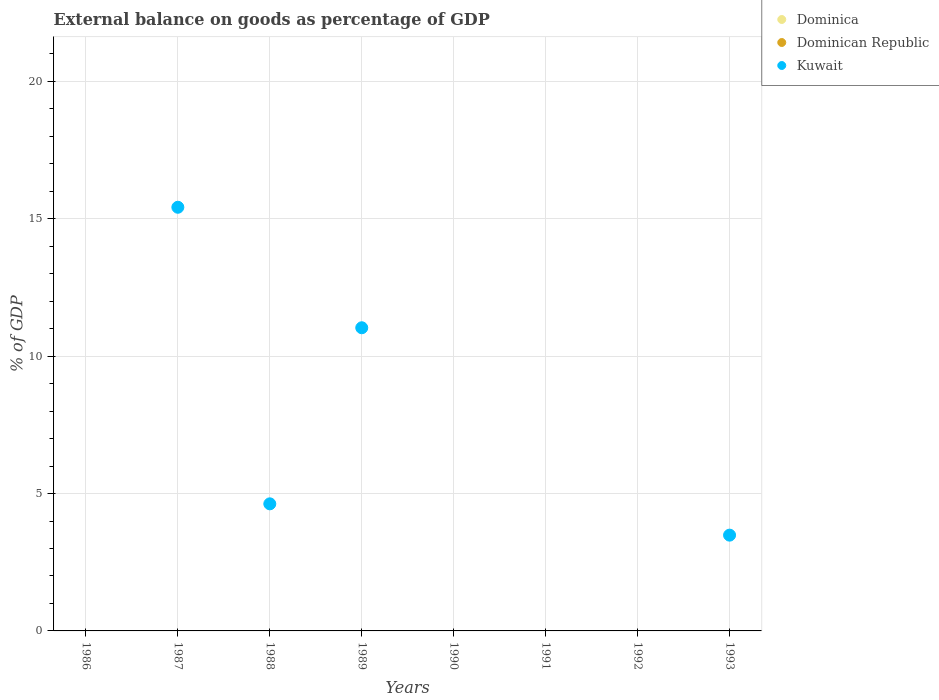Is the number of dotlines equal to the number of legend labels?
Give a very brief answer. No. Across all years, what is the maximum external balance on goods as percentage of GDP in Kuwait?
Offer a very short reply. 15.42. In which year was the external balance on goods as percentage of GDP in Kuwait maximum?
Keep it short and to the point. 1987. What is the total external balance on goods as percentage of GDP in Dominica in the graph?
Provide a short and direct response. 0. What is the difference between the external balance on goods as percentage of GDP in Kuwait in 1987 and that in 1993?
Keep it short and to the point. 11.93. What is the difference between the external balance on goods as percentage of GDP in Kuwait in 1993 and the external balance on goods as percentage of GDP in Dominica in 1990?
Your answer should be compact. 3.49. What is the average external balance on goods as percentage of GDP in Dominican Republic per year?
Give a very brief answer. 0. In how many years, is the external balance on goods as percentage of GDP in Dominican Republic greater than 10 %?
Ensure brevity in your answer.  0. What is the ratio of the external balance on goods as percentage of GDP in Kuwait in 1988 to that in 1989?
Your answer should be very brief. 0.42. What is the difference between the highest and the second highest external balance on goods as percentage of GDP in Kuwait?
Provide a succinct answer. 4.39. What is the difference between the highest and the lowest external balance on goods as percentage of GDP in Kuwait?
Provide a short and direct response. 15.42. In how many years, is the external balance on goods as percentage of GDP in Dominican Republic greater than the average external balance on goods as percentage of GDP in Dominican Republic taken over all years?
Keep it short and to the point. 0. Is the sum of the external balance on goods as percentage of GDP in Kuwait in 1988 and 1989 greater than the maximum external balance on goods as percentage of GDP in Dominican Republic across all years?
Offer a terse response. Yes. Is it the case that in every year, the sum of the external balance on goods as percentage of GDP in Dominica and external balance on goods as percentage of GDP in Kuwait  is greater than the external balance on goods as percentage of GDP in Dominican Republic?
Give a very brief answer. No. Does the external balance on goods as percentage of GDP in Kuwait monotonically increase over the years?
Your answer should be very brief. No. Is the external balance on goods as percentage of GDP in Dominican Republic strictly less than the external balance on goods as percentage of GDP in Dominica over the years?
Offer a terse response. No. How many dotlines are there?
Provide a succinct answer. 1. What is the difference between two consecutive major ticks on the Y-axis?
Your answer should be very brief. 5. How many legend labels are there?
Offer a very short reply. 3. How are the legend labels stacked?
Provide a short and direct response. Vertical. What is the title of the graph?
Give a very brief answer. External balance on goods as percentage of GDP. What is the label or title of the X-axis?
Keep it short and to the point. Years. What is the label or title of the Y-axis?
Give a very brief answer. % of GDP. What is the % of GDP of Dominica in 1986?
Provide a short and direct response. 0. What is the % of GDP in Kuwait in 1986?
Offer a terse response. 0. What is the % of GDP in Kuwait in 1987?
Make the answer very short. 15.42. What is the % of GDP in Dominican Republic in 1988?
Keep it short and to the point. 0. What is the % of GDP in Kuwait in 1988?
Give a very brief answer. 4.62. What is the % of GDP in Kuwait in 1989?
Provide a succinct answer. 11.03. What is the % of GDP of Dominican Republic in 1990?
Provide a short and direct response. 0. What is the % of GDP in Dominica in 1992?
Your answer should be very brief. 0. What is the % of GDP of Kuwait in 1992?
Keep it short and to the point. 0. What is the % of GDP in Dominican Republic in 1993?
Offer a terse response. 0. What is the % of GDP of Kuwait in 1993?
Your answer should be compact. 3.49. Across all years, what is the maximum % of GDP of Kuwait?
Provide a succinct answer. 15.42. Across all years, what is the minimum % of GDP of Kuwait?
Offer a very short reply. 0. What is the total % of GDP in Dominica in the graph?
Your answer should be very brief. 0. What is the total % of GDP of Kuwait in the graph?
Offer a terse response. 34.56. What is the difference between the % of GDP of Kuwait in 1987 and that in 1988?
Offer a very short reply. 10.79. What is the difference between the % of GDP of Kuwait in 1987 and that in 1989?
Offer a terse response. 4.39. What is the difference between the % of GDP of Kuwait in 1987 and that in 1993?
Ensure brevity in your answer.  11.93. What is the difference between the % of GDP in Kuwait in 1988 and that in 1989?
Your answer should be compact. -6.41. What is the difference between the % of GDP in Kuwait in 1988 and that in 1993?
Give a very brief answer. 1.14. What is the difference between the % of GDP of Kuwait in 1989 and that in 1993?
Offer a very short reply. 7.55. What is the average % of GDP of Dominica per year?
Keep it short and to the point. 0. What is the average % of GDP of Kuwait per year?
Your response must be concise. 4.32. What is the ratio of the % of GDP of Kuwait in 1987 to that in 1988?
Your answer should be compact. 3.33. What is the ratio of the % of GDP of Kuwait in 1987 to that in 1989?
Offer a terse response. 1.4. What is the ratio of the % of GDP of Kuwait in 1987 to that in 1993?
Give a very brief answer. 4.42. What is the ratio of the % of GDP of Kuwait in 1988 to that in 1989?
Your answer should be very brief. 0.42. What is the ratio of the % of GDP in Kuwait in 1988 to that in 1993?
Give a very brief answer. 1.33. What is the ratio of the % of GDP in Kuwait in 1989 to that in 1993?
Your response must be concise. 3.17. What is the difference between the highest and the second highest % of GDP of Kuwait?
Provide a succinct answer. 4.39. What is the difference between the highest and the lowest % of GDP of Kuwait?
Make the answer very short. 15.42. 